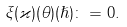Convert formula to latex. <formula><loc_0><loc_0><loc_500><loc_500>\xi ( \varkappa ) ( \theta ) ( \hslash ) \colon = 0 .</formula> 